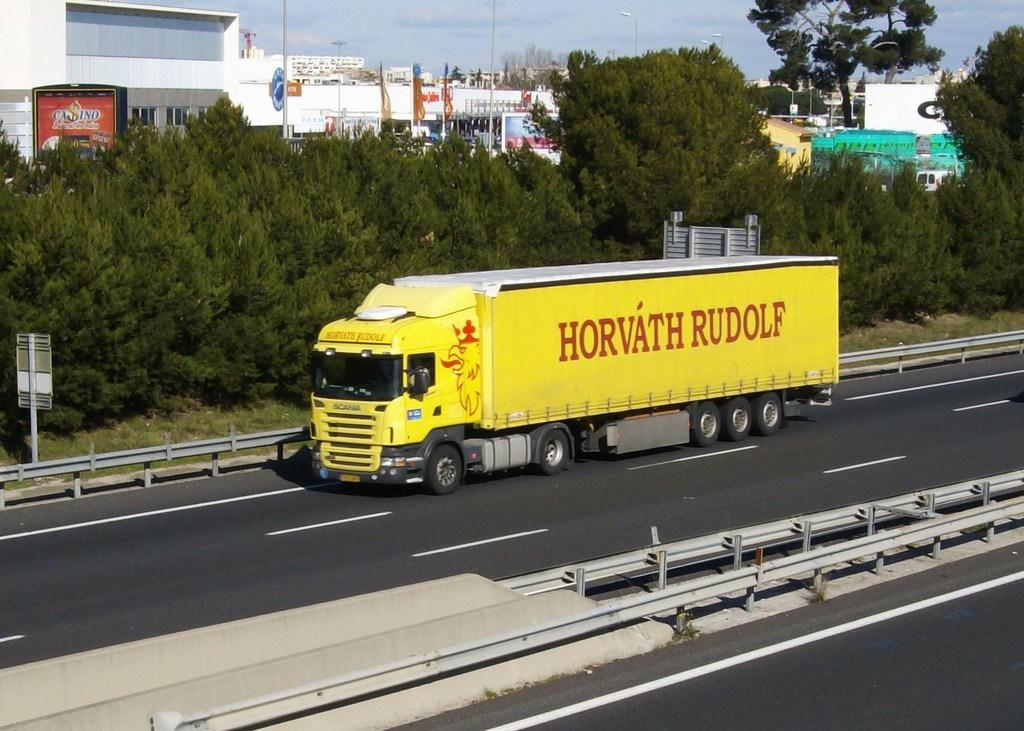What is on the road in the image? There is a vehicle on the road in the image. What is attached to the pole in the image? There are boards on a pole in the image. What can be seen in the background of the image? There are buildings, trees, lights on poles, and the sky visible in the background. What type of flower is growing on the vehicle in the image? There are no flowers present on the vehicle in the image. Can you tell me how many worms are crawling on the boards on the pole? There are no worms present on the boards on the pole in the image. 